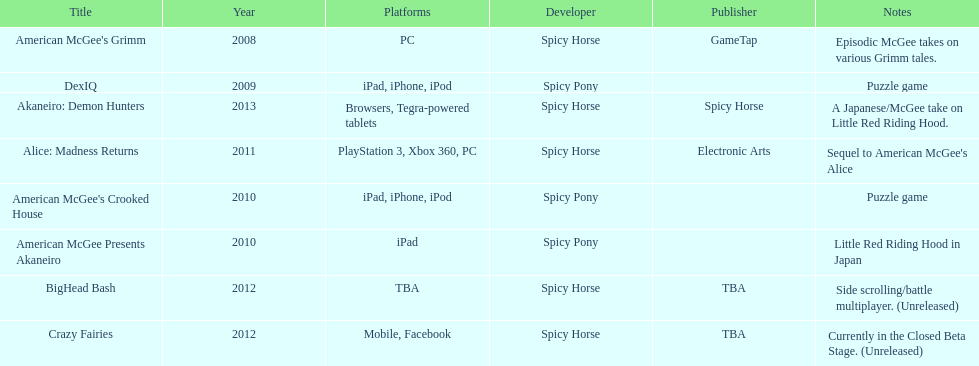Spicy pony released a total of three games; their game, "american mcgee's crooked house" was released on which platforms? Ipad, iphone, ipod. 